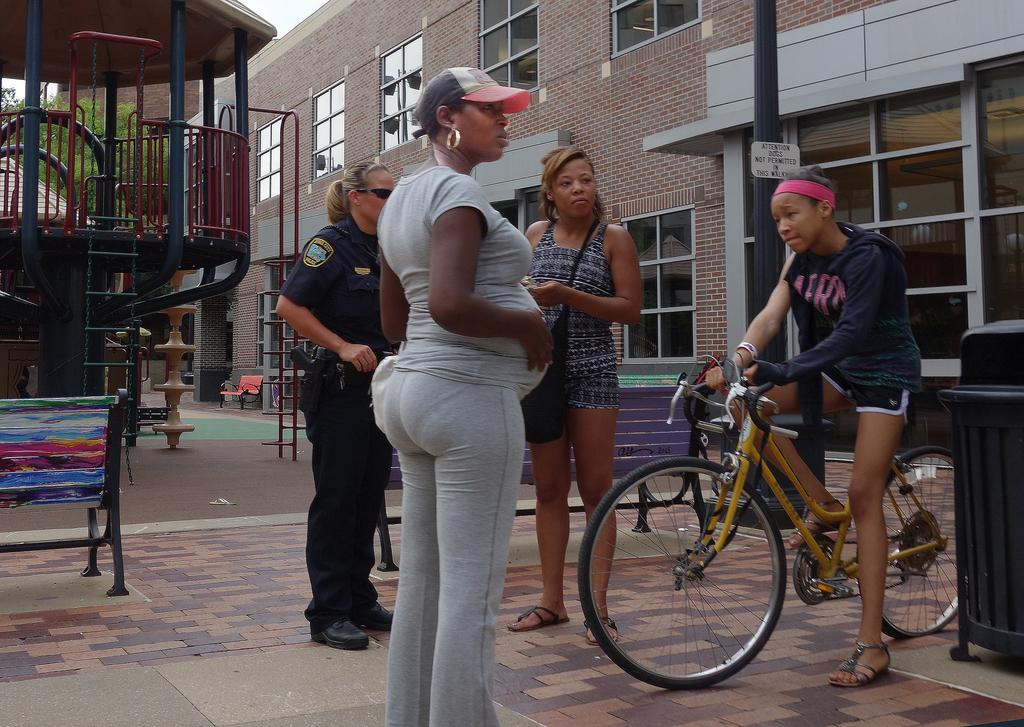How many people are present in the image? There are multiple people in the image. What is one person doing in the image? One person is riding a cycle. What can be seen in the background of the image? There is a building and a ride in the background of the image. What type of dress is the porter wearing in the image? There is no porter present in the image, and therefore no dress can be described. 